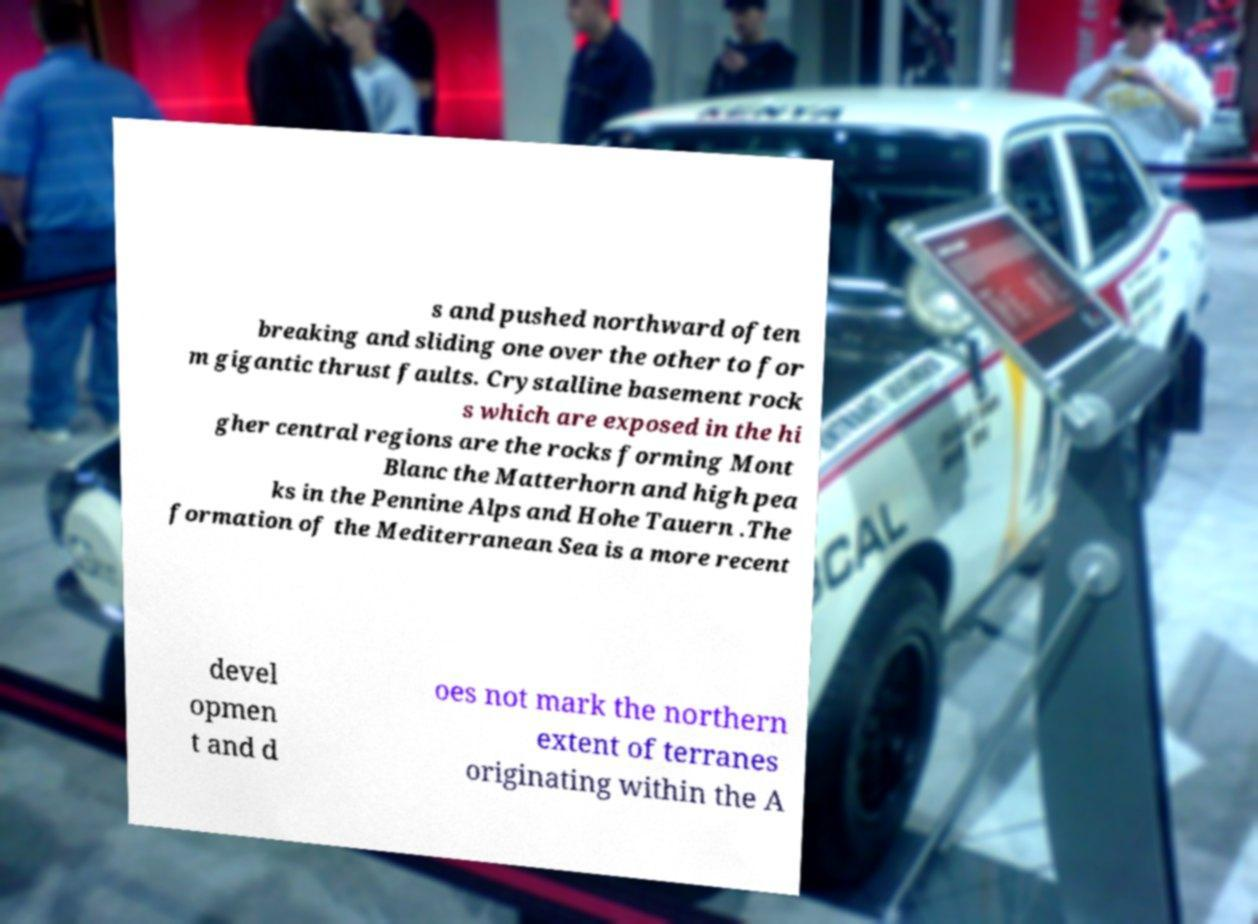Can you accurately transcribe the text from the provided image for me? s and pushed northward often breaking and sliding one over the other to for m gigantic thrust faults. Crystalline basement rock s which are exposed in the hi gher central regions are the rocks forming Mont Blanc the Matterhorn and high pea ks in the Pennine Alps and Hohe Tauern .The formation of the Mediterranean Sea is a more recent devel opmen t and d oes not mark the northern extent of terranes originating within the A 